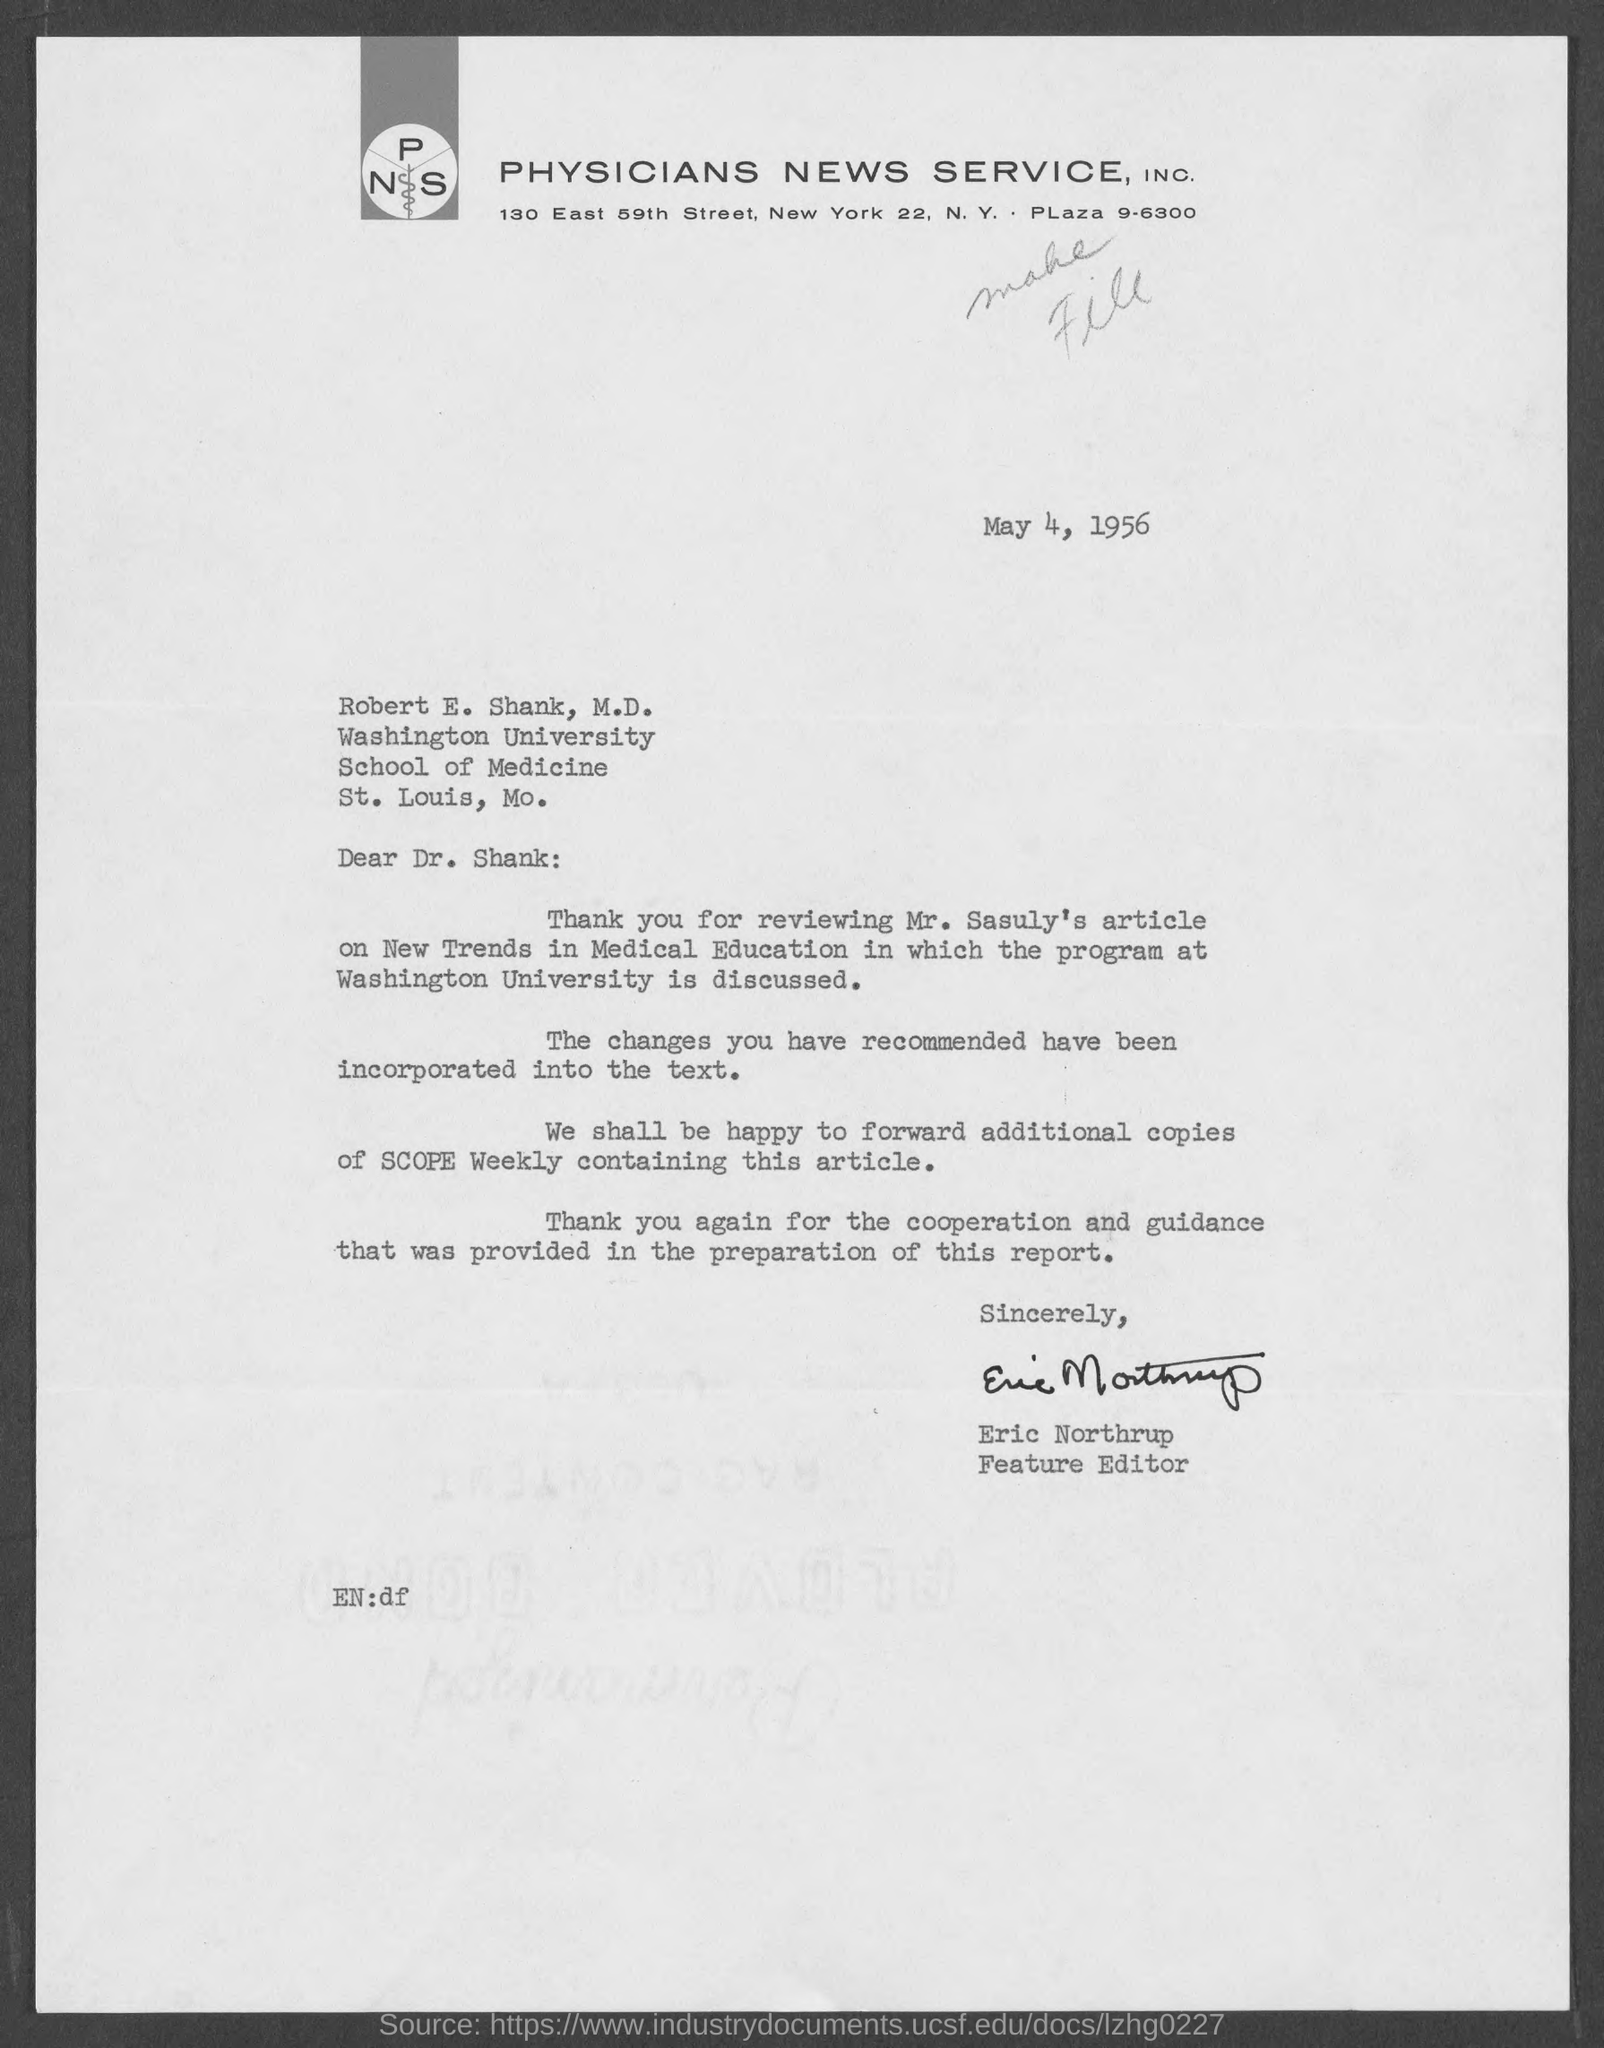What is the date mentioned ?
Make the answer very short. May 4 , 1956. To whom this letter is written
Ensure brevity in your answer.  Robert E. Shank. To which university robert e. shank belongs to /
Provide a succinct answer. Washington University. Who is the feature editor ?
Keep it short and to the point. Eric Northrup. In which city physicians news service , inc is located
Provide a short and direct response. New York. 